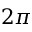<formula> <loc_0><loc_0><loc_500><loc_500>2 \pi</formula> 